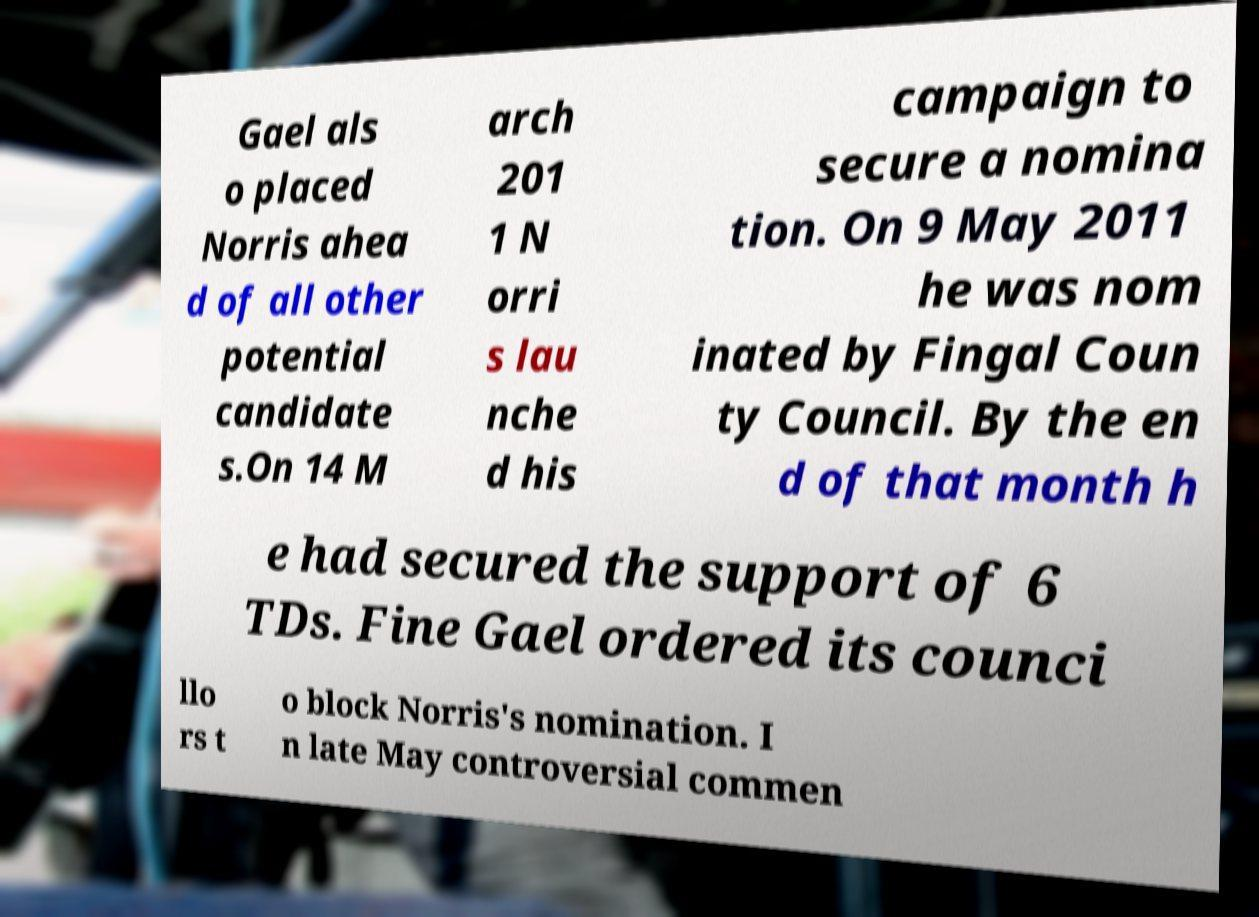What messages or text are displayed in this image? I need them in a readable, typed format. Gael als o placed Norris ahea d of all other potential candidate s.On 14 M arch 201 1 N orri s lau nche d his campaign to secure a nomina tion. On 9 May 2011 he was nom inated by Fingal Coun ty Council. By the en d of that month h e had secured the support of 6 TDs. Fine Gael ordered its counci llo rs t o block Norris's nomination. I n late May controversial commen 